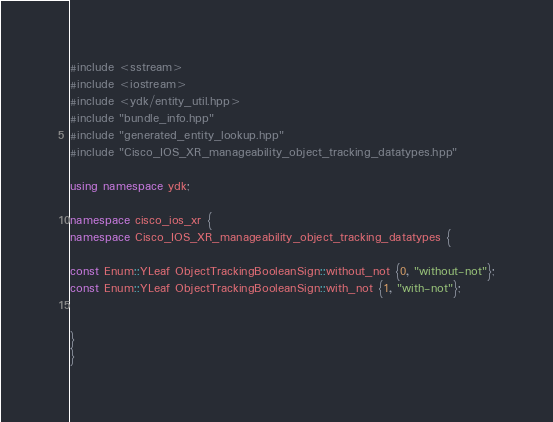<code> <loc_0><loc_0><loc_500><loc_500><_C++_>
#include <sstream>
#include <iostream>
#include <ydk/entity_util.hpp>
#include "bundle_info.hpp"
#include "generated_entity_lookup.hpp"
#include "Cisco_IOS_XR_manageability_object_tracking_datatypes.hpp"

using namespace ydk;

namespace cisco_ios_xr {
namespace Cisco_IOS_XR_manageability_object_tracking_datatypes {

const Enum::YLeaf ObjectTrackingBooleanSign::without_not {0, "without-not"};
const Enum::YLeaf ObjectTrackingBooleanSign::with_not {1, "with-not"};


}
}

</code> 